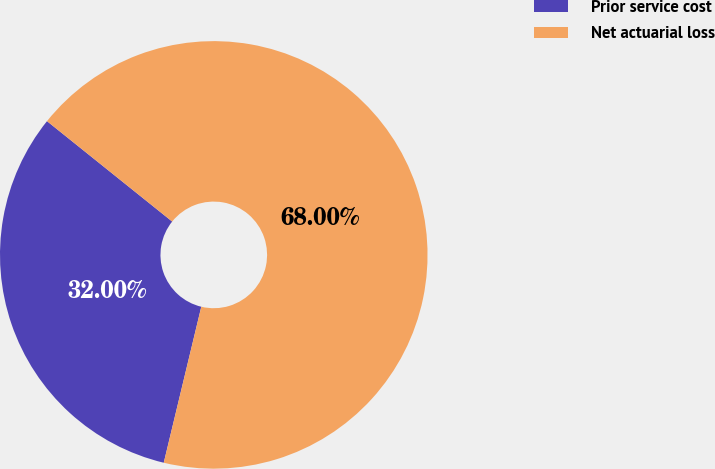Convert chart to OTSL. <chart><loc_0><loc_0><loc_500><loc_500><pie_chart><fcel>Prior service cost<fcel>Net actuarial loss<nl><fcel>32.0%<fcel>68.0%<nl></chart> 